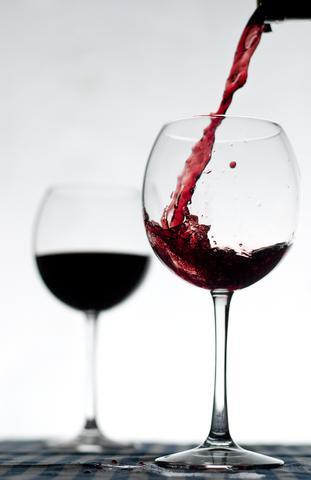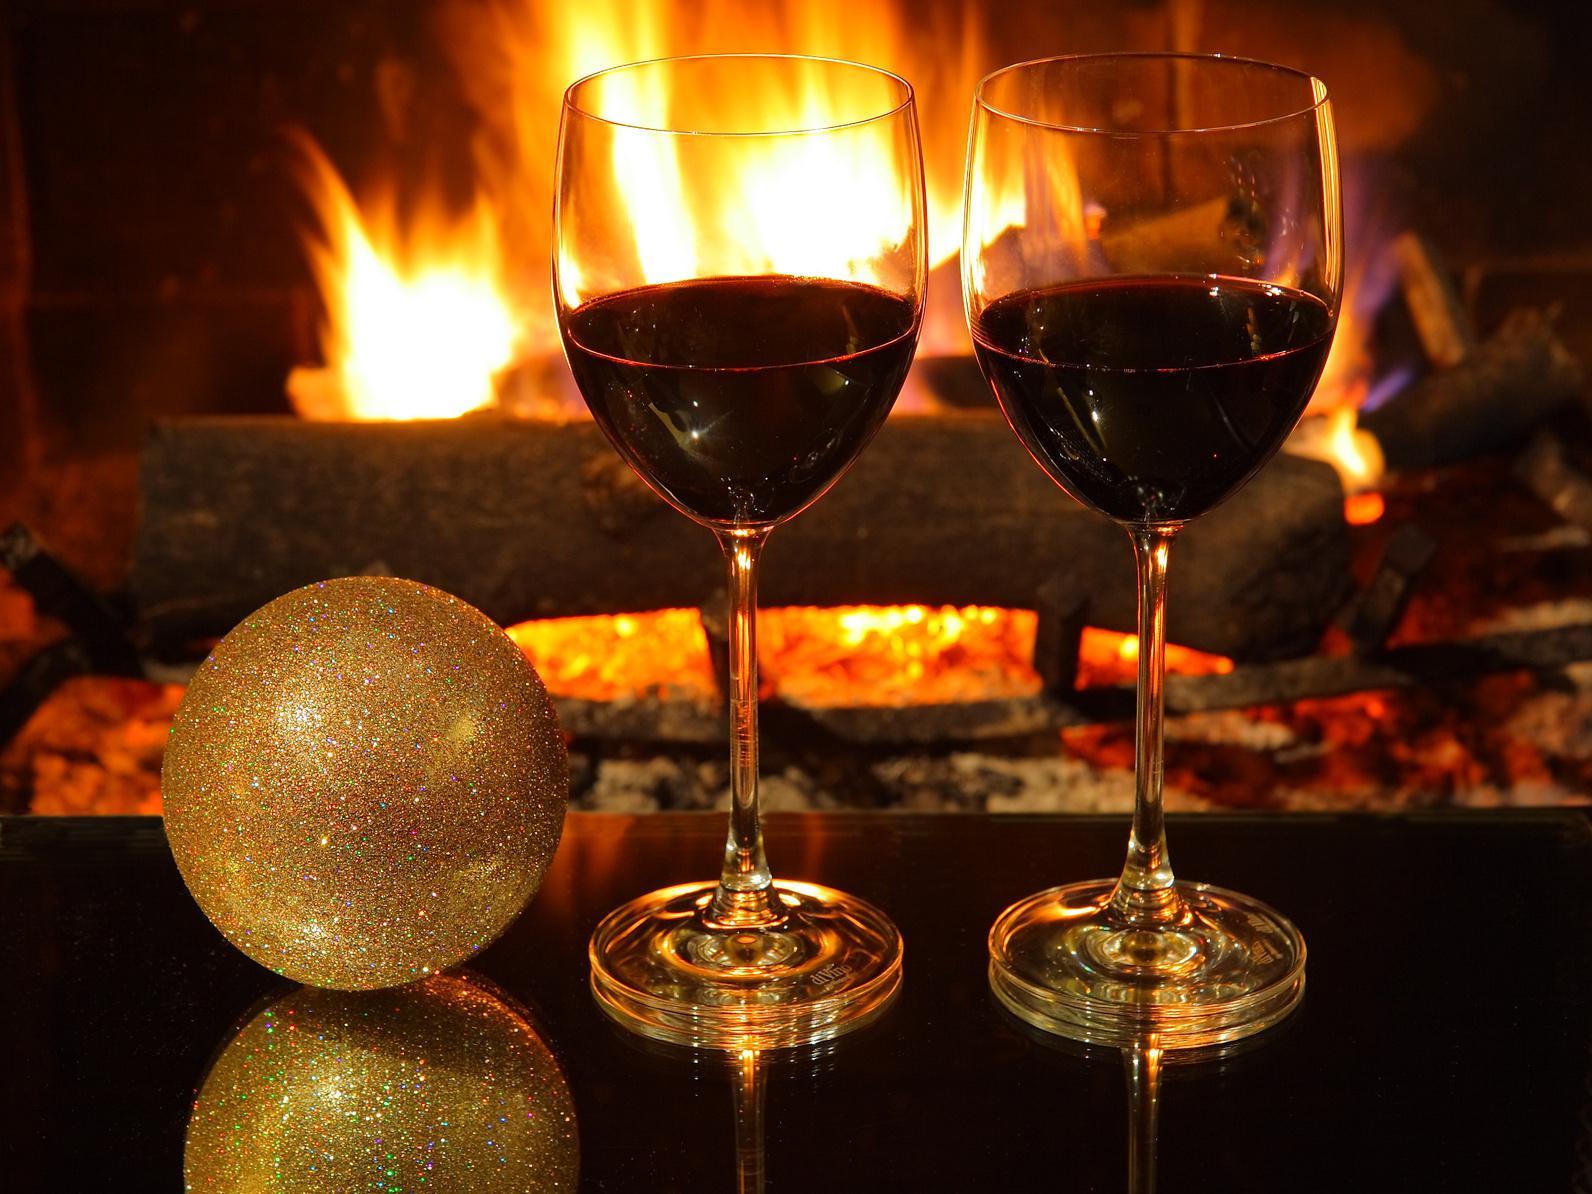The first image is the image on the left, the second image is the image on the right. Analyze the images presented: Is the assertion "A pair of clinking wine glasses create a splash of wine that reaches above the rim of the glass." valid? Answer yes or no. No. The first image is the image on the left, the second image is the image on the right. Examine the images to the left and right. Is the description "The right image contains two wine glasses with red wine in them." accurate? Answer yes or no. Yes. 